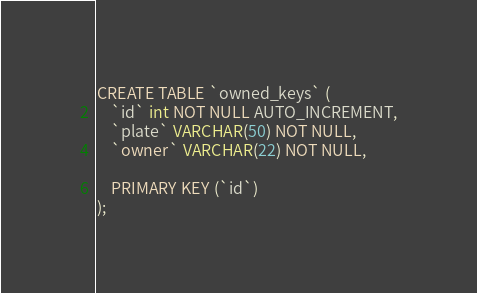Convert code to text. <code><loc_0><loc_0><loc_500><loc_500><_SQL_>CREATE TABLE `owned_keys` (
	`id` int NOT NULL AUTO_INCREMENT,
	`plate` VARCHAR(50) NOT NULL,
	`owner` VARCHAR(22) NOT NULL,

	PRIMARY KEY (`id`)
);</code> 